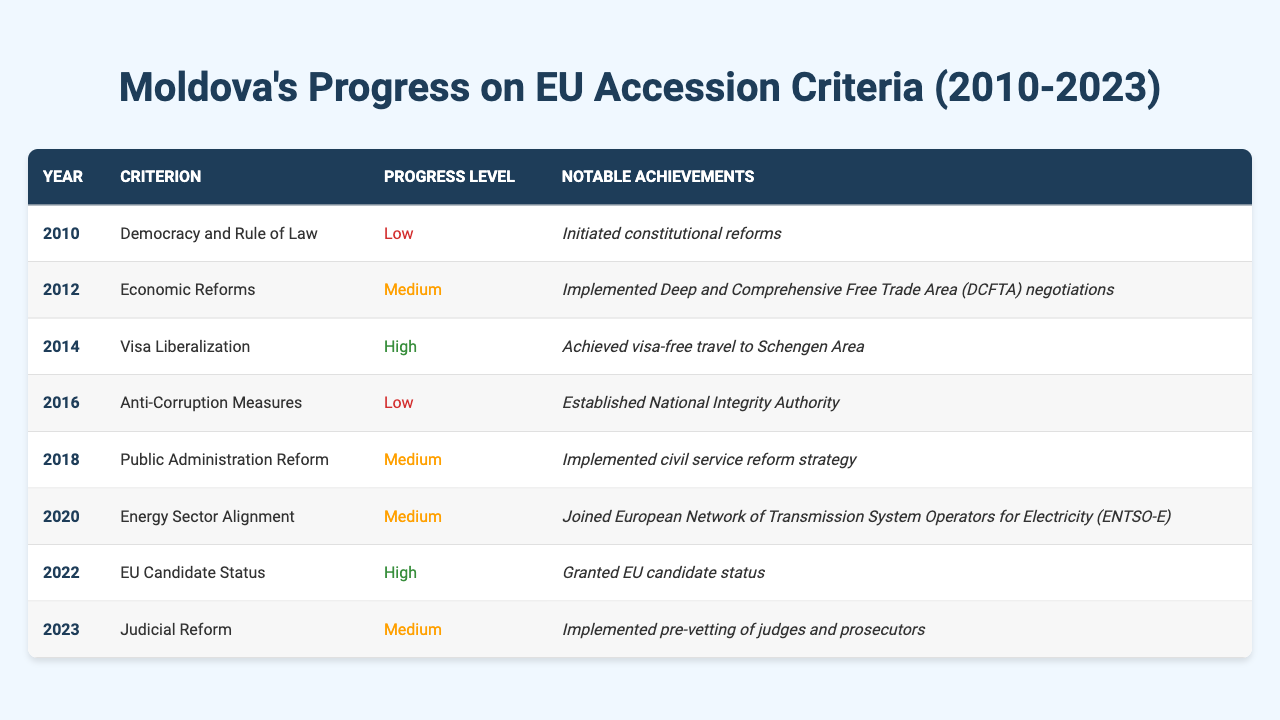What year did Moldova achieve visa-free travel to the Schengen Area? In the table, the row for the year 2014 indicates that Moldova achieved visa-free travel to the Schengen Area.
Answer: 2014 What notable achievement occurred in 2022? According to the table, the notable achievement in 2022 was that Moldova was granted EU candidate status.
Answer: Granted EU candidate status In which criterion did Moldova have high progress in 2022? The table shows that in 2022, the criterion for EU candidate status had a high progress level, indicating significant advancement.
Answer: EU Candidate Status How many years did it take Moldova from initial constitutional reforms to gaining EU candidate status? Starting from 2010 with constitutional reforms and reaching EU candidate status in 2022 means it took a total of 12 years.
Answer: 12 years Which criterion has the highest progress level based on the table? By examining the table, the criteria with high progress levels are "Visa Liberalization" in 2014 and "EU Candidate Status" in 2022, both marked as high.
Answer: Visa Liberalization and EU Candidate Status Was there any progress in the Anti-Corruption Measures during 2016? The table indicates that in 2016, the progress level for Anti-Corruption Measures was low, confirming that there was no significant progress in that area.
Answer: No What trend can be observed in Moldova's progress levels over the years from 2010 to 2023? By analyzing the table, we can observe that Moldova's progress levels have varied between low, medium, and high, with notable improvements leading up to 2022's EU candidate status.
Answer: Varied progress levels with improvement By what criterion did Moldova see a medium progress level in both 2018 and 2023? The criterion that saw a medium progress level in both years is "Public Administration Reform" in 2018 and "Judicial Reform" in 2023, indicating consistent advancement in these areas.
Answer: Public Administration Reform and Judicial Reform How many total criteria were marked with a high progress level from 2010 to 2023? The table lists a total of two criteria (2014 and 2022) that are marked with a high progress level when counting through all entries.
Answer: 2 What is the difference in progress level between the first and last year in the table? The first year, 2010, has a low progress level, while 2023 has a medium progress level, indicating a shift of one level up in the progress criteria.
Answer: One level up 